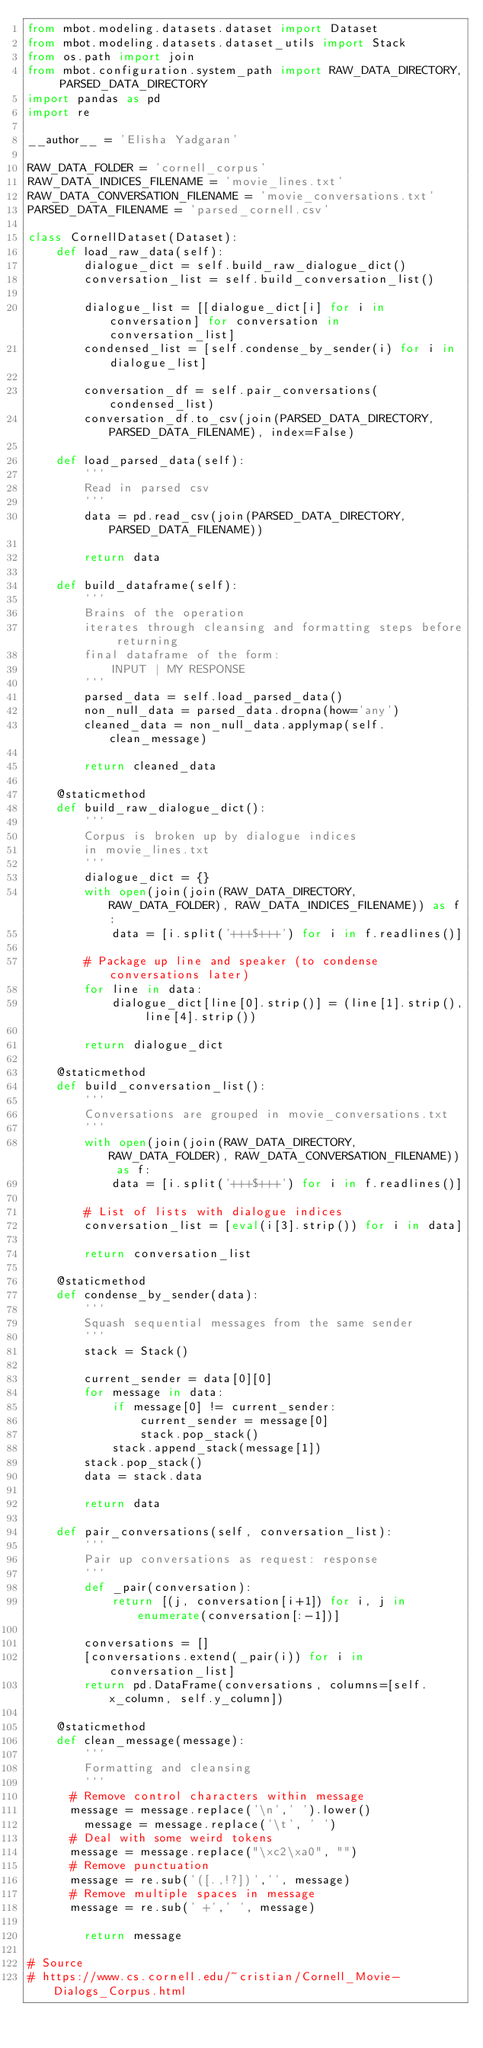<code> <loc_0><loc_0><loc_500><loc_500><_Python_>from mbot.modeling.datasets.dataset import Dataset
from mbot.modeling.datasets.dataset_utils import Stack
from os.path import join
from mbot.configuration.system_path import RAW_DATA_DIRECTORY, PARSED_DATA_DIRECTORY
import pandas as pd
import re

__author__ = 'Elisha Yadgaran'

RAW_DATA_FOLDER = 'cornell_corpus'
RAW_DATA_INDICES_FILENAME = 'movie_lines.txt'
RAW_DATA_CONVERSATION_FILENAME = 'movie_conversations.txt'
PARSED_DATA_FILENAME = 'parsed_cornell.csv'

class CornellDataset(Dataset):
    def load_raw_data(self):
        dialogue_dict = self.build_raw_dialogue_dict()
        conversation_list = self.build_conversation_list()

        dialogue_list = [[dialogue_dict[i] for i in conversation] for conversation in conversation_list]
        condensed_list = [self.condense_by_sender(i) for i in dialogue_list]

        conversation_df = self.pair_conversations(condensed_list)
        conversation_df.to_csv(join(PARSED_DATA_DIRECTORY, PARSED_DATA_FILENAME), index=False)

    def load_parsed_data(self):
        '''
        Read in parsed csv
        '''
        data = pd.read_csv(join(PARSED_DATA_DIRECTORY, PARSED_DATA_FILENAME))

        return data

    def build_dataframe(self):
        '''
        Brains of the operation
        iterates through cleansing and formatting steps before returning
        final dataframe of the form:
            INPUT | MY RESPONSE
        '''
        parsed_data = self.load_parsed_data()
        non_null_data = parsed_data.dropna(how='any')
        cleaned_data = non_null_data.applymap(self.clean_message)

        return cleaned_data

    @staticmethod
    def build_raw_dialogue_dict():
        '''
        Corpus is broken up by dialogue indices
        in movie_lines.txt
        '''
        dialogue_dict = {}
        with open(join(join(RAW_DATA_DIRECTORY, RAW_DATA_FOLDER), RAW_DATA_INDICES_FILENAME)) as f:
            data = [i.split('+++$+++') for i in f.readlines()]

        # Package up line and speaker (to condense conversations later)
        for line in data:
            dialogue_dict[line[0].strip()] = (line[1].strip(), line[4].strip())

        return dialogue_dict

    @staticmethod
    def build_conversation_list():
        '''
        Conversations are grouped in movie_conversations.txt
        '''
        with open(join(join(RAW_DATA_DIRECTORY, RAW_DATA_FOLDER), RAW_DATA_CONVERSATION_FILENAME)) as f:
            data = [i.split('+++$+++') for i in f.readlines()]

        # List of lists with dialogue indices
        conversation_list = [eval(i[3].strip()) for i in data]

        return conversation_list

    @staticmethod
    def condense_by_sender(data):
        '''
        Squash sequential messages from the same sender
        '''
        stack = Stack()

        current_sender = data[0][0]
        for message in data:
            if message[0] != current_sender:
                current_sender = message[0]
                stack.pop_stack()
            stack.append_stack(message[1])
        stack.pop_stack()
        data = stack.data

        return data

    def pair_conversations(self, conversation_list):
        '''
        Pair up conversations as request: response
        '''
        def _pair(conversation):
            return [(j, conversation[i+1]) for i, j in enumerate(conversation[:-1])]

        conversations = []
        [conversations.extend(_pair(i)) for i in conversation_list]
        return pd.DataFrame(conversations, columns=[self.x_column, self.y_column])

    @staticmethod
    def clean_message(message):
        '''
        Formatting and cleansing
        '''
    	# Remove control characters within message
    	message = message.replace('\n',' ').lower()
        message = message.replace('\t', ' ')
    	# Deal with some weird tokens
    	message = message.replace("\xc2\xa0", "")
    	# Remove punctuation
    	message = re.sub('([.,!?])','', message)
    	# Remove multiple spaces in message
    	message = re.sub(' +',' ', message)

        return message

# Source
# https://www.cs.cornell.edu/~cristian/Cornell_Movie-Dialogs_Corpus.html
</code> 